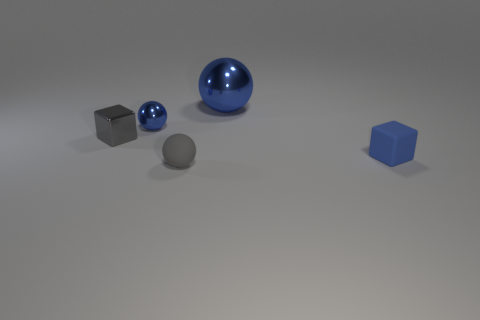Subtract all metal spheres. How many spheres are left? 1 Add 1 tiny blue rubber objects. How many objects exist? 6 Subtract all spheres. How many objects are left? 2 Add 2 tiny yellow balls. How many tiny yellow balls exist? 2 Subtract 0 brown cylinders. How many objects are left? 5 Subtract all small brown shiny cylinders. Subtract all big objects. How many objects are left? 4 Add 3 gray spheres. How many gray spheres are left? 4 